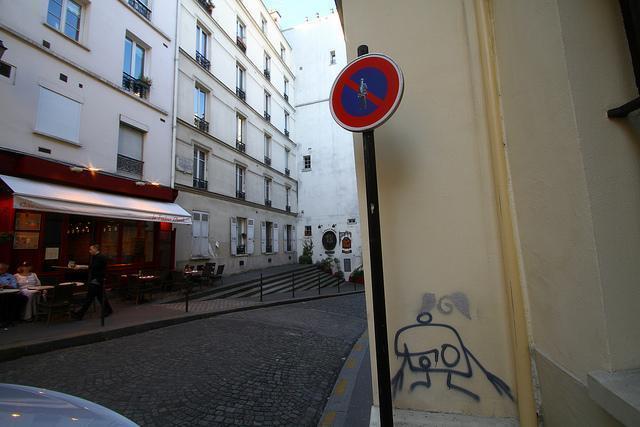How many manhole covers are shown?
Give a very brief answer. 0. How many cars are there?
Give a very brief answer. 1. How many vases are holding flowers?
Give a very brief answer. 0. 